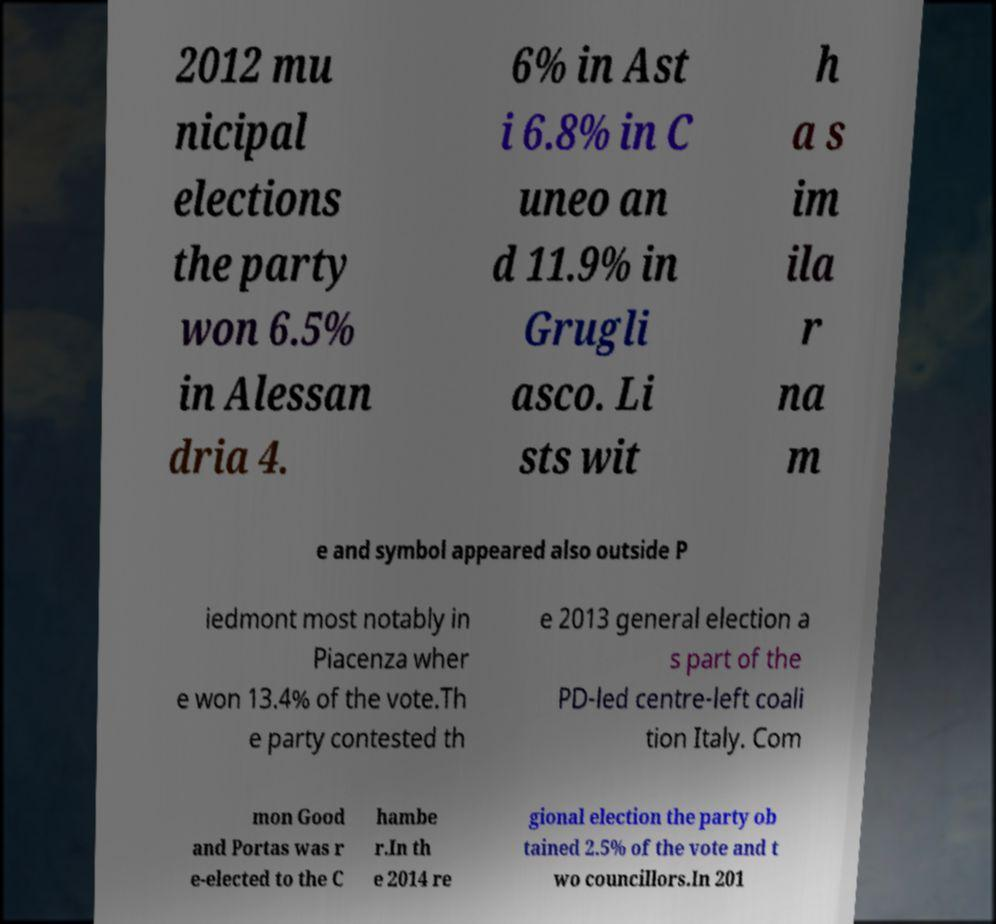There's text embedded in this image that I need extracted. Can you transcribe it verbatim? 2012 mu nicipal elections the party won 6.5% in Alessan dria 4. 6% in Ast i 6.8% in C uneo an d 11.9% in Grugli asco. Li sts wit h a s im ila r na m e and symbol appeared also outside P iedmont most notably in Piacenza wher e won 13.4% of the vote.Th e party contested th e 2013 general election a s part of the PD-led centre-left coali tion Italy. Com mon Good and Portas was r e-elected to the C hambe r.In th e 2014 re gional election the party ob tained 2.5% of the vote and t wo councillors.In 201 